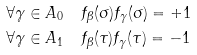<formula> <loc_0><loc_0><loc_500><loc_500>\forall \gamma \in A _ { 0 } & \quad f _ { \beta } ( \sigma ) f _ { \gamma } ( \sigma ) = + 1 \\ \forall \gamma \in A _ { 1 } & \quad f _ { \beta } ( \tau ) f _ { \gamma } ( \tau ) = - 1</formula> 